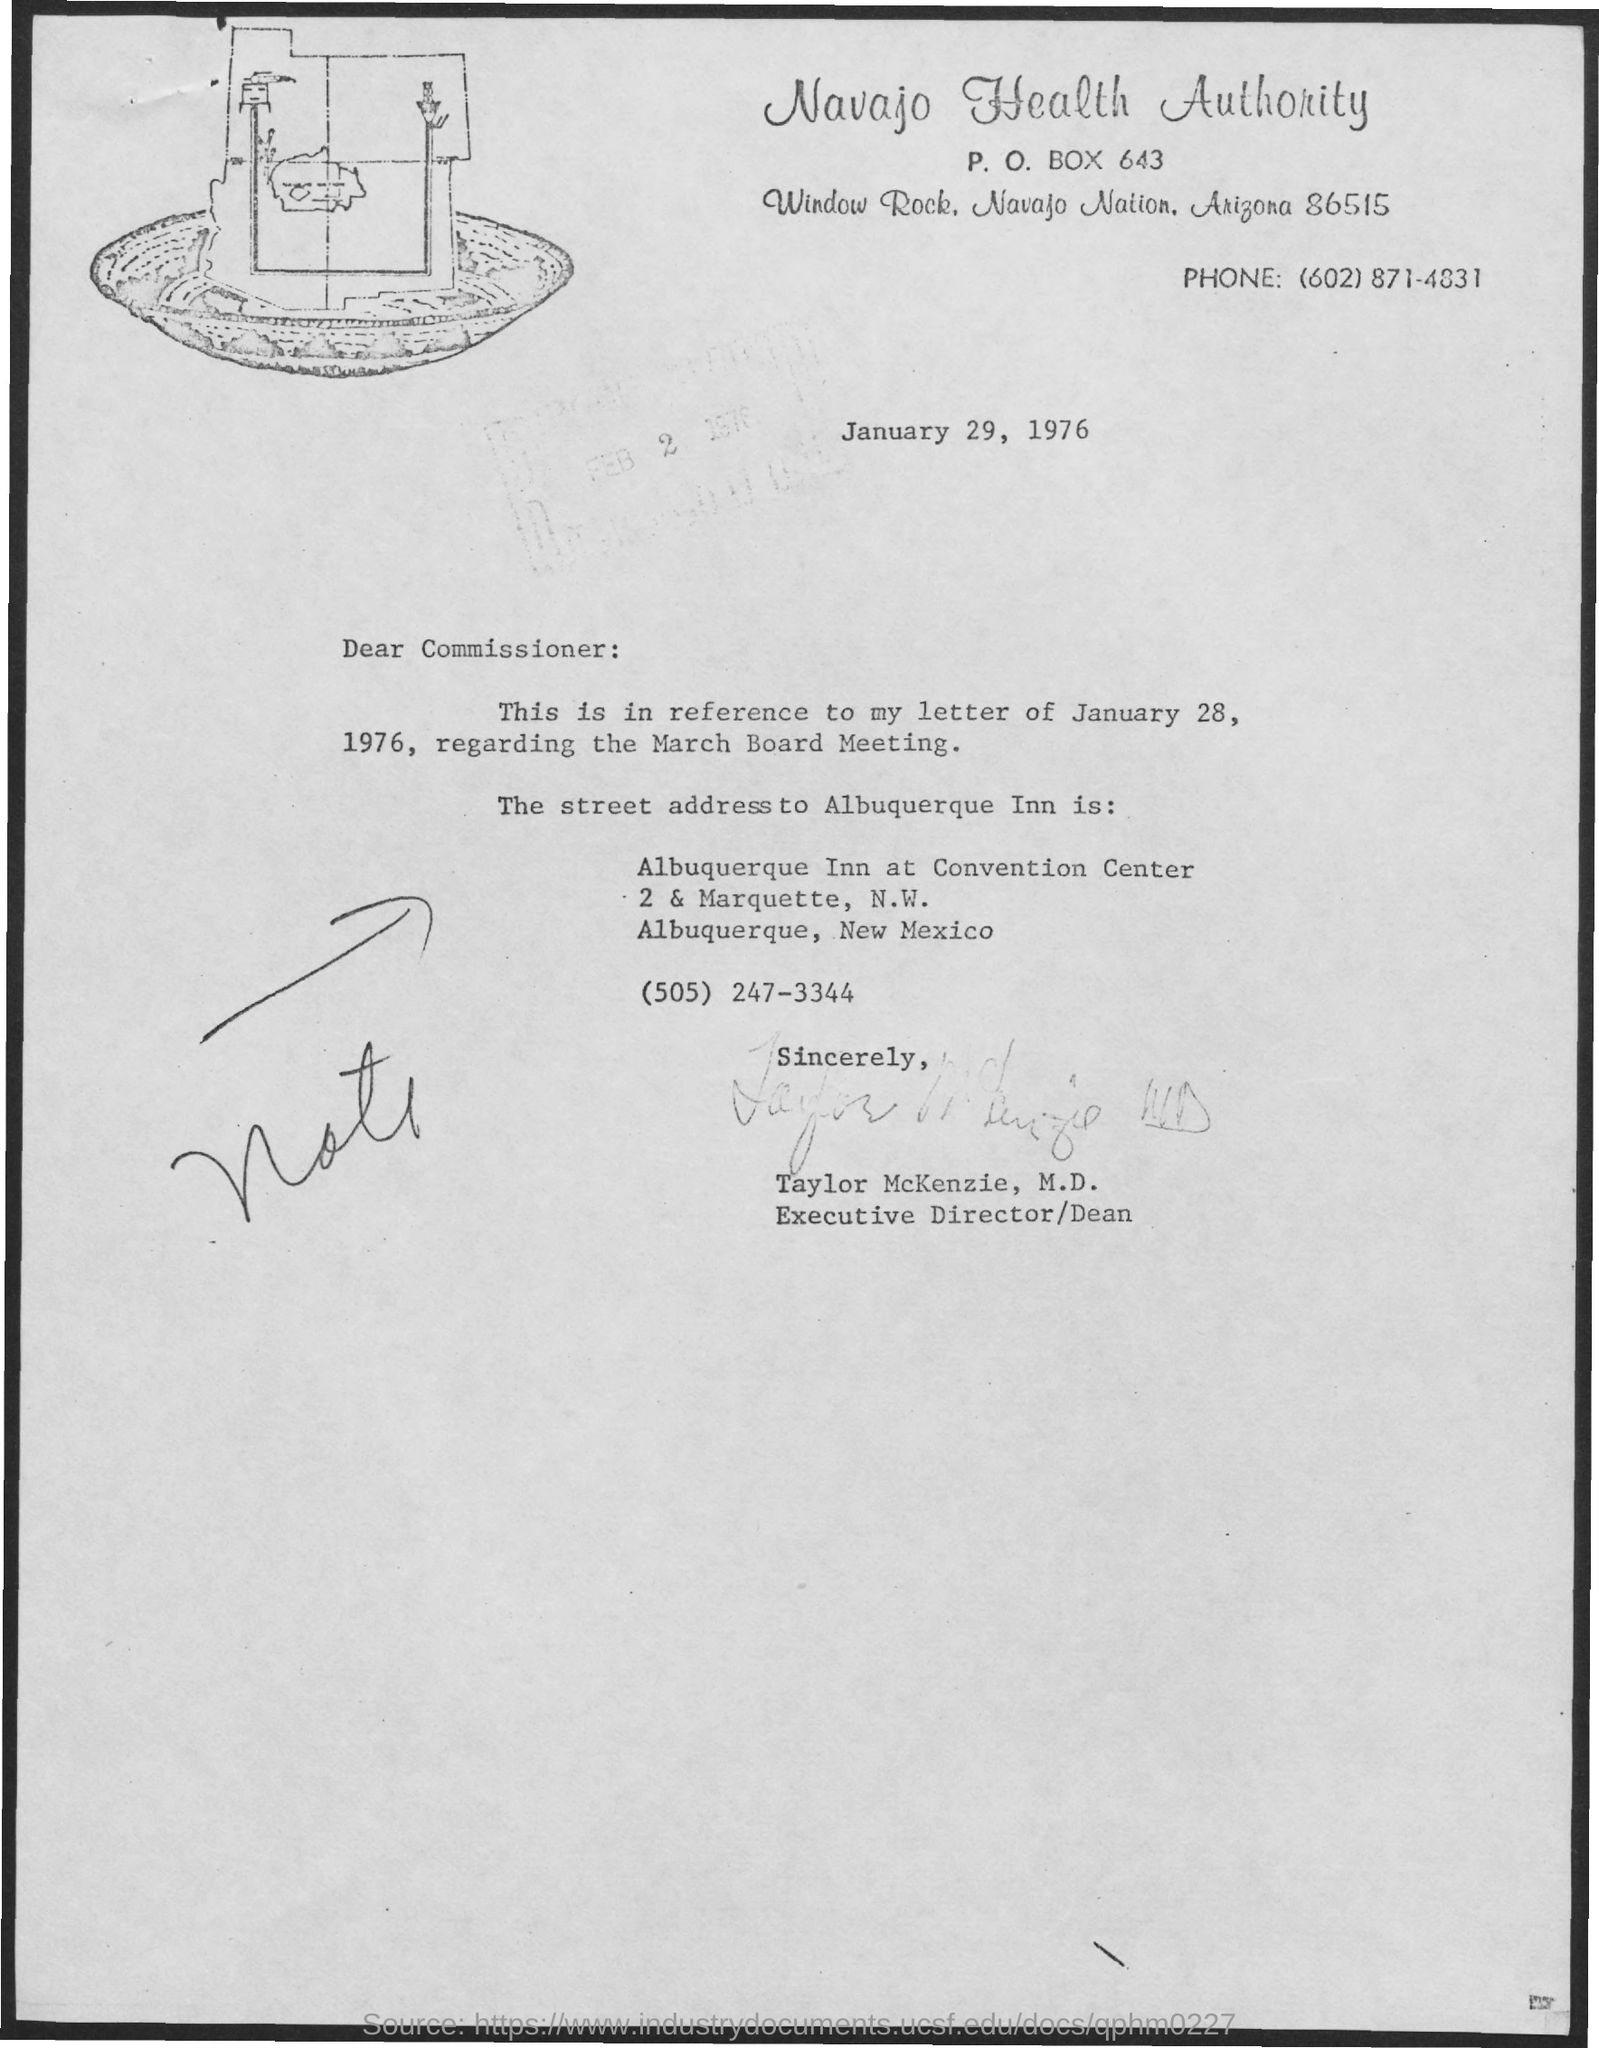List a handful of essential elements in this visual. The P.O. Box number mentioned is 643. The signature at the bottom of the letter was that of Taylor McKenzie. 